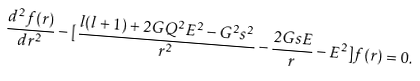Convert formula to latex. <formula><loc_0><loc_0><loc_500><loc_500>\frac { d ^ { 2 } f ( r ) } { d r ^ { 2 } } - [ \frac { l ( l + 1 ) + 2 G Q ^ { 2 } E ^ { 2 } - G ^ { 2 } s ^ { 2 } } { r ^ { 2 } } - \frac { 2 G s E } { r } - E ^ { 2 } ] f ( r ) = 0 .</formula> 